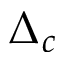Convert formula to latex. <formula><loc_0><loc_0><loc_500><loc_500>\Delta _ { c }</formula> 